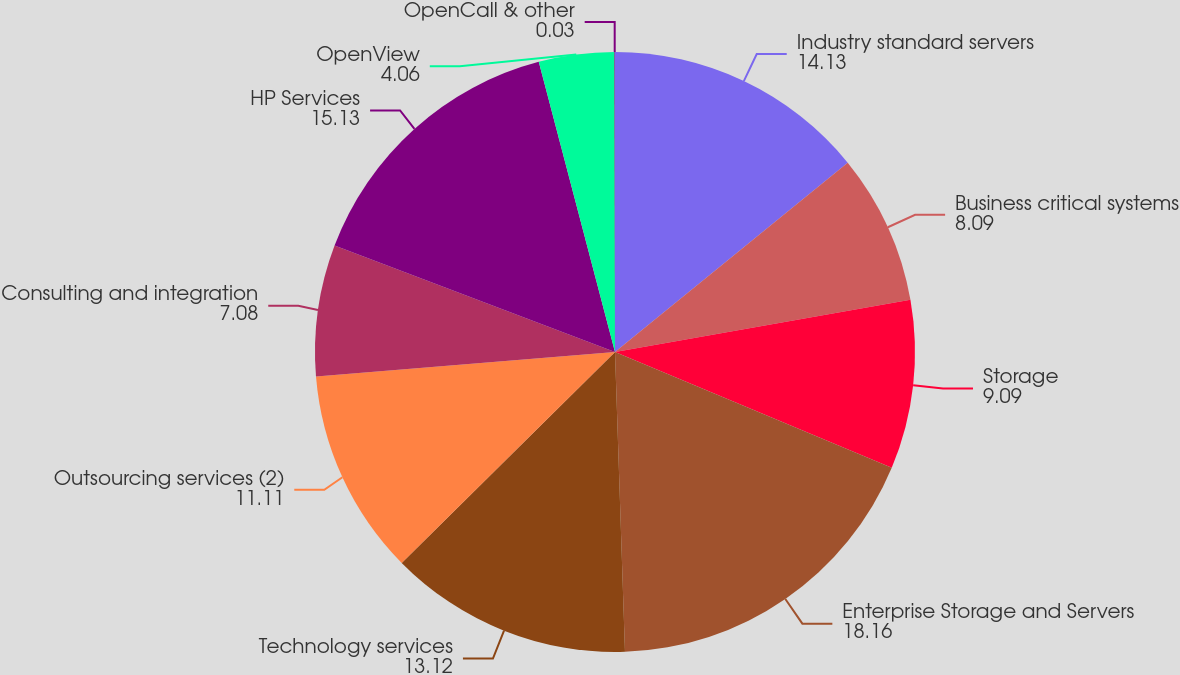<chart> <loc_0><loc_0><loc_500><loc_500><pie_chart><fcel>Industry standard servers<fcel>Business critical systems<fcel>Storage<fcel>Enterprise Storage and Servers<fcel>Technology services<fcel>Outsourcing services (2)<fcel>Consulting and integration<fcel>HP Services<fcel>OpenView<fcel>OpenCall & other<nl><fcel>14.13%<fcel>8.09%<fcel>9.09%<fcel>18.16%<fcel>13.12%<fcel>11.11%<fcel>7.08%<fcel>15.13%<fcel>4.06%<fcel>0.03%<nl></chart> 